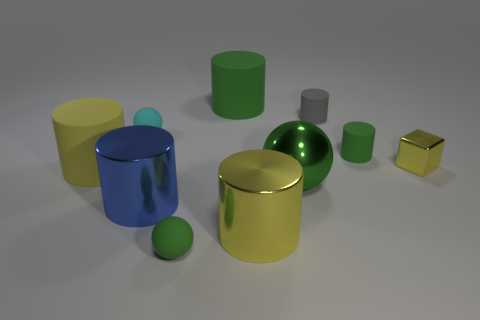Does the large blue object have the same shape as the tiny cyan matte object that is behind the blue thing?
Provide a succinct answer. No. How big is the gray matte cylinder that is behind the cyan rubber object?
Keep it short and to the point. Small. What is the material of the big green cylinder?
Provide a succinct answer. Rubber. There is a small green rubber object that is left of the big yellow metal thing; is its shape the same as the big green metallic object?
Provide a short and direct response. Yes. What is the size of the other sphere that is the same color as the large shiny sphere?
Offer a terse response. Small. Is there a gray object of the same size as the shiny cube?
Your response must be concise. Yes. There is a large sphere in front of the big cylinder behind the cyan object; are there any small matte objects that are to the left of it?
Offer a very short reply. Yes. There is a metallic ball; is its color the same as the large object that is behind the small metal block?
Offer a terse response. Yes. What material is the yellow cylinder that is left of the matte sphere behind the green cylinder in front of the tiny gray cylinder?
Ensure brevity in your answer.  Rubber. What shape is the green rubber thing right of the metal sphere?
Provide a succinct answer. Cylinder. 